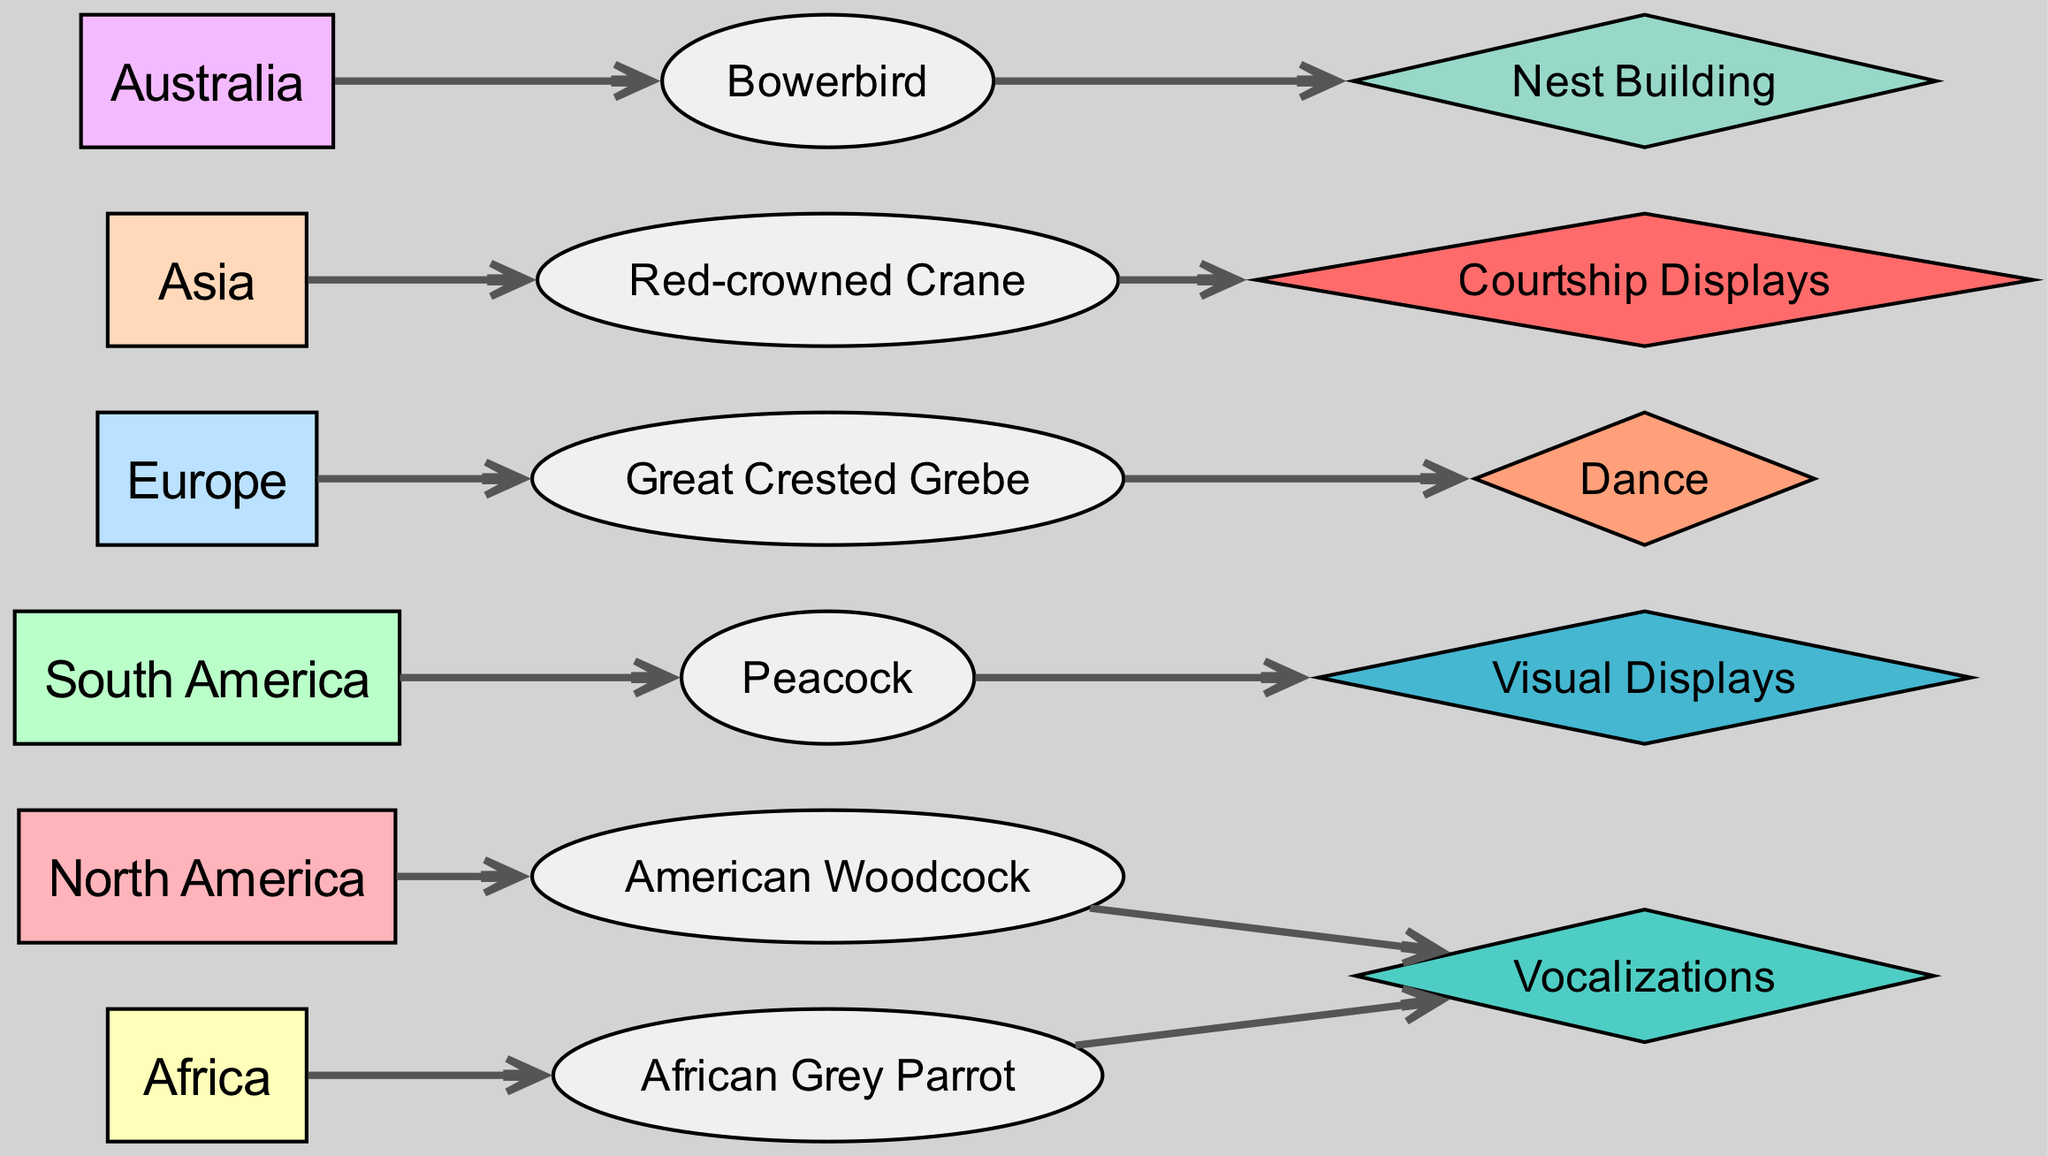What bird species is associated with North America? The diagram shows a direct connection from the North America node to the American Woodcock node, indicating that this bird species is found in North America.
Answer: American Woodcock Which display type is used by the Peacock? The link from the Peacock node points to the Visual Displays node, indicating that this is the display type associated with the Peacock.
Answer: Visual Displays How many geographic regions are represented in this diagram? By counting the nodes categorized as Geographic Region, we find there are six regions listed: North America, South America, Europe, Africa, Asia, and Australia.
Answer: 6 Which bird species is linked to Vocalizations from two different geographic regions? The diagram has two sources directed toward the Vocalizations node, one from the American Woodcock in North America and another from the African Grey Parrot in Africa, confirming they are both linked to Vocalizations.
Answer: American Woodcock, African Grey Parrot What is the relationship between the Red-crowned Crane and Courtship Displays? The diagram shows a direct link from the Red-crowned Crane node to the Courtship Displays node, indicating that this species uses Courtship Displays as a mating display.
Answer: Courtship Displays What type of display is used by the Great Crested Grebe? The Great Crested Grebe node has a direct link to the Dance node, showing that this species uses dance as a form of mating display.
Answer: Dance Which geographic region has the bird species Bowerbird? The diagram connects the Bowerbird node to the Australia geographic region, indicating that it is found in Australia.
Answer: Australia Which display type has links from the most various bird species? By examining the links, Vocalizations and Courtship Displays each link to two different bird species, but focusing only on the different species connected to these types shows that Vocalizations links American Woodcock and African Grey Parrot, while Courtship Displays links only the Red-crowned Crane. Hence, Vocalizations is the type with more connections.
Answer: Vocalizations How many edges originate from the Australia node? The Australia node directly links to the Bowerbird, and since it's the only edge, we can conclude that there is a single edge originating from Australia.
Answer: 1 